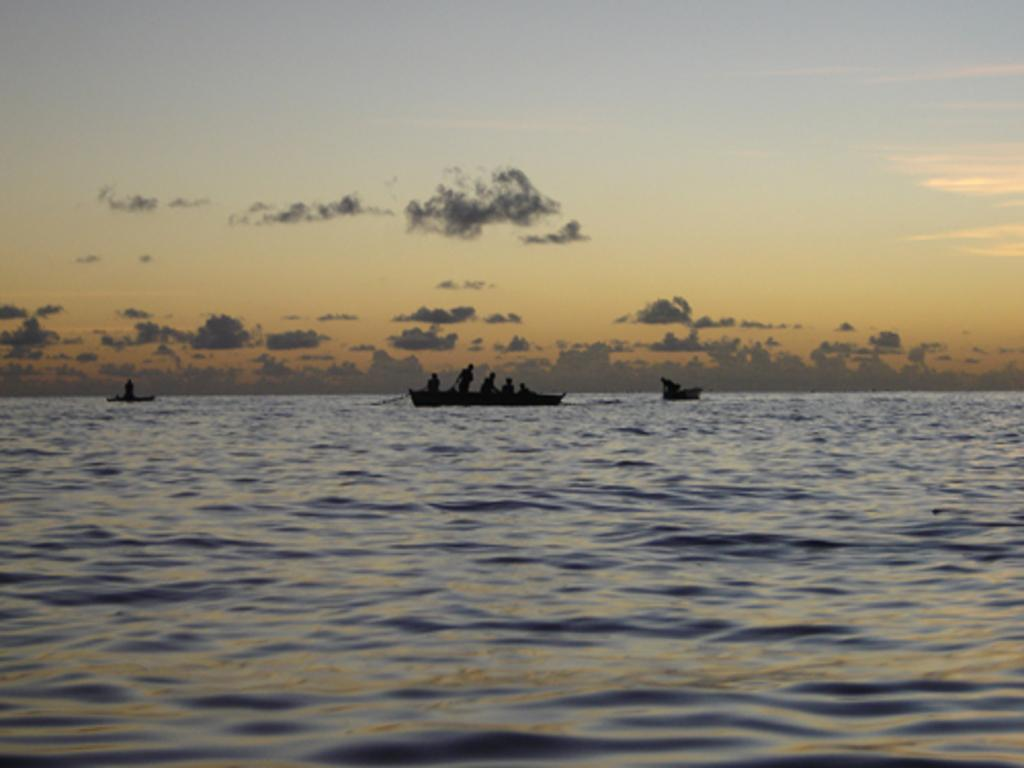What is visible in the front of the image? There is water in the front of the image. What can be seen in the background of the image? There are boats sailing on the water in the background. Can you describe the people in the image? Yes, there are persons inside the boats. How would you describe the weather in the image? The sky is cloudy in the image. How many rabbits are hopping through the gate in the image? There are no rabbits or gates present in the image. What type of cent is visible in the water in the image? There is no cent present in the image; it features water, boats, and persons inside the boats. 